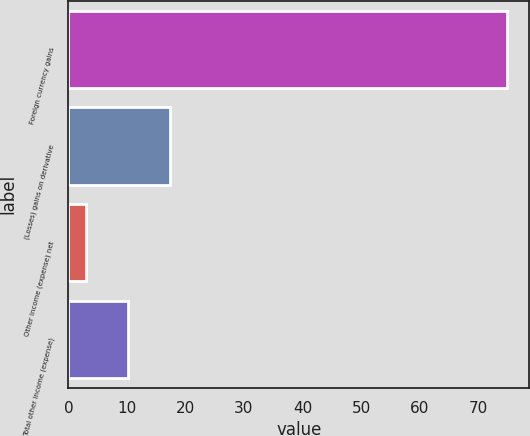<chart> <loc_0><loc_0><loc_500><loc_500><bar_chart><fcel>Foreign currency gains<fcel>(Losses) gains on derivative<fcel>Other income (expense) net<fcel>Total other income (expense)<nl><fcel>75<fcel>17.4<fcel>3<fcel>10.2<nl></chart> 